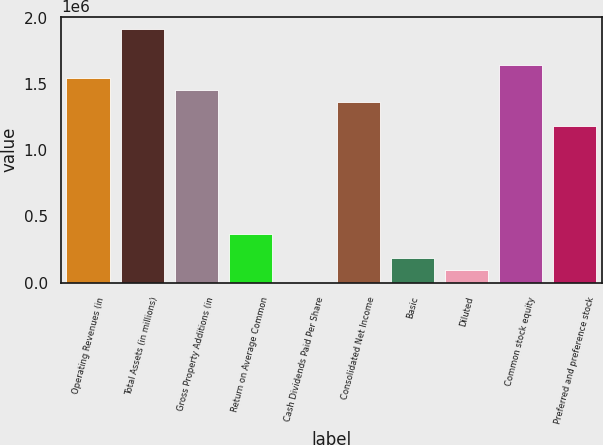Convert chart to OTSL. <chart><loc_0><loc_0><loc_500><loc_500><bar_chart><fcel>Operating Revenues (in<fcel>Total Assets (in millions)<fcel>Gross Property Additions (in<fcel>Return on Average Common<fcel>Cash Dividends Paid Per Share<fcel>Consolidated Net Income<fcel>Basic<fcel>Diluted<fcel>Common stock equity<fcel>Preferred and preference stock<nl><fcel>1.54992e+06<fcel>1.91461e+06<fcel>1.45875e+06<fcel>364690<fcel>2.15<fcel>1.36758e+06<fcel>182346<fcel>91174<fcel>1.6411e+06<fcel>1.18524e+06<nl></chart> 